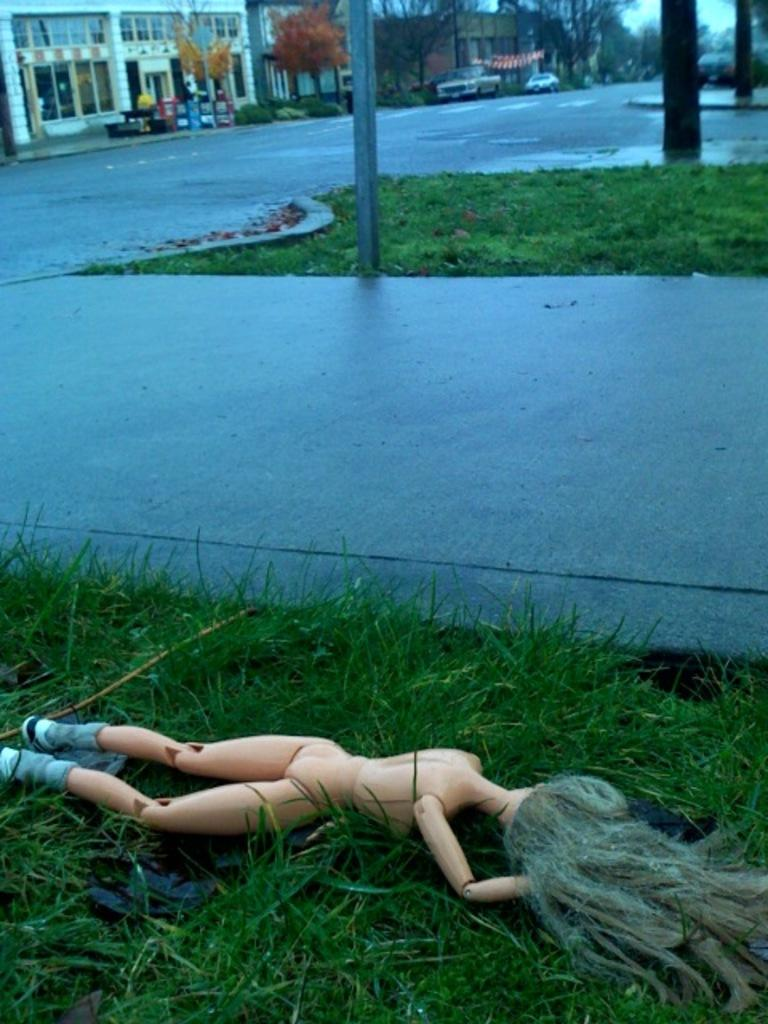What type of structures can be seen in the image? There are buildings in the image. What natural elements are present in the image? There are trees and grass in the image. What man-made objects can be seen in the image? There are poles, vehicles, and a toy in the image. What type of plants are visible in the image? There are plants in the image. What part of the natural environment is visible in the image? The ground and the sky are visible in the image. Can you tell me how many giants are holding the egg in the image? There are no giants or eggs present in the image. What type of surprise can be seen in the image? There is no surprise depicted in the image; it features buildings, trees, poles, vehicles, plants, the ground, grass, the sky, and a toy. 